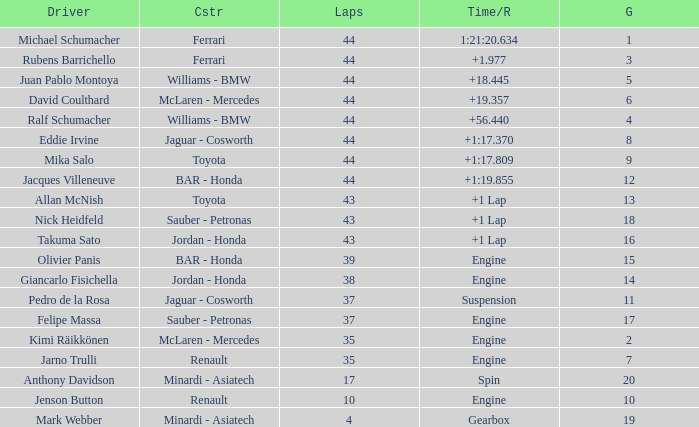What was the time of the driver on grid 3? 1.977. 